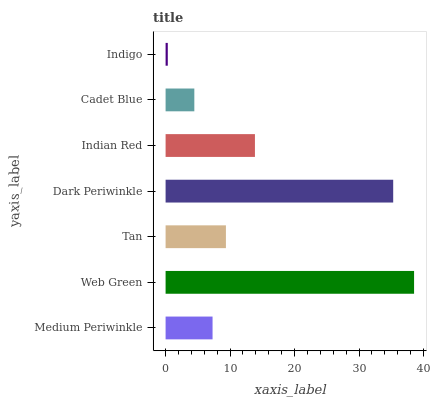Is Indigo the minimum?
Answer yes or no. Yes. Is Web Green the maximum?
Answer yes or no. Yes. Is Tan the minimum?
Answer yes or no. No. Is Tan the maximum?
Answer yes or no. No. Is Web Green greater than Tan?
Answer yes or no. Yes. Is Tan less than Web Green?
Answer yes or no. Yes. Is Tan greater than Web Green?
Answer yes or no. No. Is Web Green less than Tan?
Answer yes or no. No. Is Tan the high median?
Answer yes or no. Yes. Is Tan the low median?
Answer yes or no. Yes. Is Indigo the high median?
Answer yes or no. No. Is Indian Red the low median?
Answer yes or no. No. 